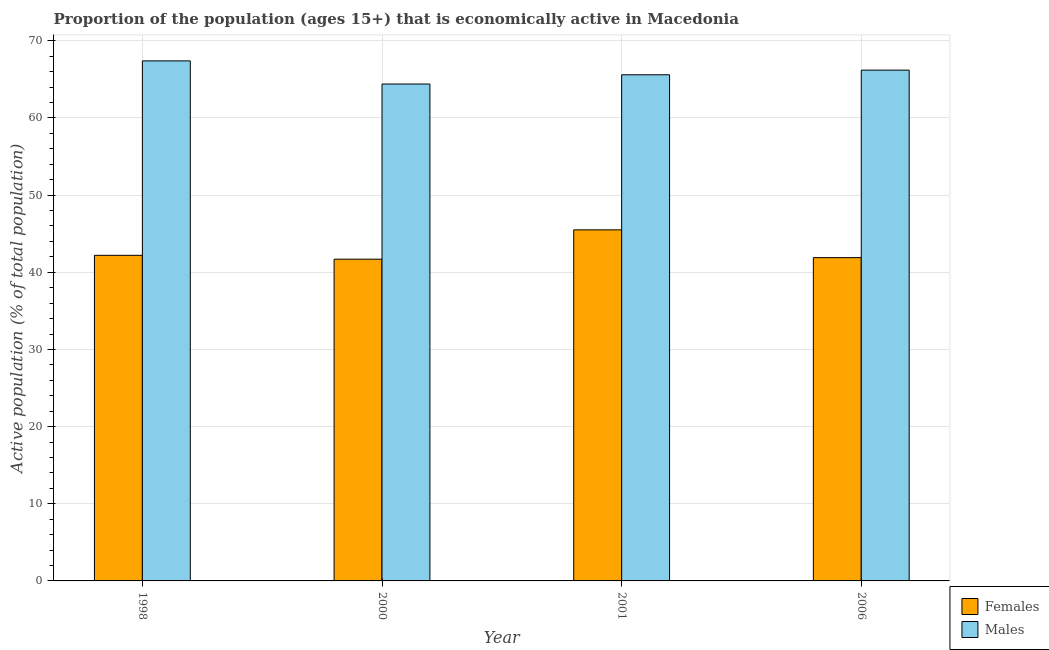How many groups of bars are there?
Keep it short and to the point. 4. Are the number of bars per tick equal to the number of legend labels?
Your answer should be compact. Yes. What is the percentage of economically active male population in 2001?
Give a very brief answer. 65.6. Across all years, what is the maximum percentage of economically active male population?
Ensure brevity in your answer.  67.4. Across all years, what is the minimum percentage of economically active male population?
Give a very brief answer. 64.4. What is the total percentage of economically active female population in the graph?
Provide a succinct answer. 171.3. What is the difference between the percentage of economically active female population in 1998 and that in 2006?
Provide a short and direct response. 0.3. What is the difference between the percentage of economically active male population in 2001 and the percentage of economically active female population in 1998?
Keep it short and to the point. -1.8. What is the average percentage of economically active male population per year?
Keep it short and to the point. 65.9. In the year 2006, what is the difference between the percentage of economically active female population and percentage of economically active male population?
Provide a succinct answer. 0. What is the ratio of the percentage of economically active male population in 1998 to that in 2001?
Make the answer very short. 1.03. Is the difference between the percentage of economically active male population in 1998 and 2000 greater than the difference between the percentage of economically active female population in 1998 and 2000?
Offer a terse response. No. What is the difference between the highest and the second highest percentage of economically active male population?
Give a very brief answer. 1.2. In how many years, is the percentage of economically active male population greater than the average percentage of economically active male population taken over all years?
Provide a short and direct response. 2. What does the 2nd bar from the left in 2006 represents?
Make the answer very short. Males. What does the 2nd bar from the right in 1998 represents?
Make the answer very short. Females. How many years are there in the graph?
Provide a short and direct response. 4. What is the difference between two consecutive major ticks on the Y-axis?
Offer a very short reply. 10. Does the graph contain grids?
Offer a terse response. Yes. How many legend labels are there?
Ensure brevity in your answer.  2. What is the title of the graph?
Ensure brevity in your answer.  Proportion of the population (ages 15+) that is economically active in Macedonia. Does "Resident workers" appear as one of the legend labels in the graph?
Ensure brevity in your answer.  No. What is the label or title of the Y-axis?
Offer a very short reply. Active population (% of total population). What is the Active population (% of total population) in Females in 1998?
Give a very brief answer. 42.2. What is the Active population (% of total population) of Males in 1998?
Provide a succinct answer. 67.4. What is the Active population (% of total population) in Females in 2000?
Offer a very short reply. 41.7. What is the Active population (% of total population) of Males in 2000?
Your answer should be compact. 64.4. What is the Active population (% of total population) of Females in 2001?
Offer a terse response. 45.5. What is the Active population (% of total population) in Males in 2001?
Ensure brevity in your answer.  65.6. What is the Active population (% of total population) in Females in 2006?
Make the answer very short. 41.9. What is the Active population (% of total population) of Males in 2006?
Give a very brief answer. 66.2. Across all years, what is the maximum Active population (% of total population) of Females?
Ensure brevity in your answer.  45.5. Across all years, what is the maximum Active population (% of total population) in Males?
Your answer should be very brief. 67.4. Across all years, what is the minimum Active population (% of total population) of Females?
Your answer should be compact. 41.7. Across all years, what is the minimum Active population (% of total population) in Males?
Provide a succinct answer. 64.4. What is the total Active population (% of total population) in Females in the graph?
Offer a terse response. 171.3. What is the total Active population (% of total population) in Males in the graph?
Provide a short and direct response. 263.6. What is the difference between the Active population (% of total population) in Females in 1998 and that in 2000?
Offer a very short reply. 0.5. What is the difference between the Active population (% of total population) in Males in 1998 and that in 2000?
Your answer should be very brief. 3. What is the difference between the Active population (% of total population) in Females in 1998 and that in 2006?
Your answer should be compact. 0.3. What is the difference between the Active population (% of total population) of Males in 2000 and that in 2006?
Your answer should be compact. -1.8. What is the difference between the Active population (% of total population) of Males in 2001 and that in 2006?
Offer a terse response. -0.6. What is the difference between the Active population (% of total population) in Females in 1998 and the Active population (% of total population) in Males in 2000?
Ensure brevity in your answer.  -22.2. What is the difference between the Active population (% of total population) of Females in 1998 and the Active population (% of total population) of Males in 2001?
Ensure brevity in your answer.  -23.4. What is the difference between the Active population (% of total population) in Females in 2000 and the Active population (% of total population) in Males in 2001?
Your answer should be very brief. -23.9. What is the difference between the Active population (% of total population) of Females in 2000 and the Active population (% of total population) of Males in 2006?
Offer a very short reply. -24.5. What is the difference between the Active population (% of total population) of Females in 2001 and the Active population (% of total population) of Males in 2006?
Your response must be concise. -20.7. What is the average Active population (% of total population) of Females per year?
Provide a succinct answer. 42.83. What is the average Active population (% of total population) in Males per year?
Offer a terse response. 65.9. In the year 1998, what is the difference between the Active population (% of total population) in Females and Active population (% of total population) in Males?
Give a very brief answer. -25.2. In the year 2000, what is the difference between the Active population (% of total population) of Females and Active population (% of total population) of Males?
Ensure brevity in your answer.  -22.7. In the year 2001, what is the difference between the Active population (% of total population) of Females and Active population (% of total population) of Males?
Ensure brevity in your answer.  -20.1. In the year 2006, what is the difference between the Active population (% of total population) in Females and Active population (% of total population) in Males?
Provide a succinct answer. -24.3. What is the ratio of the Active population (% of total population) of Males in 1998 to that in 2000?
Your answer should be very brief. 1.05. What is the ratio of the Active population (% of total population) in Females in 1998 to that in 2001?
Keep it short and to the point. 0.93. What is the ratio of the Active population (% of total population) of Males in 1998 to that in 2001?
Your answer should be compact. 1.03. What is the ratio of the Active population (% of total population) in Males in 1998 to that in 2006?
Ensure brevity in your answer.  1.02. What is the ratio of the Active population (% of total population) of Females in 2000 to that in 2001?
Ensure brevity in your answer.  0.92. What is the ratio of the Active population (% of total population) of Males in 2000 to that in 2001?
Your response must be concise. 0.98. What is the ratio of the Active population (% of total population) of Males in 2000 to that in 2006?
Make the answer very short. 0.97. What is the ratio of the Active population (% of total population) in Females in 2001 to that in 2006?
Give a very brief answer. 1.09. What is the ratio of the Active population (% of total population) of Males in 2001 to that in 2006?
Provide a succinct answer. 0.99. What is the difference between the highest and the second highest Active population (% of total population) in Females?
Give a very brief answer. 3.3. What is the difference between the highest and the lowest Active population (% of total population) in Females?
Give a very brief answer. 3.8. What is the difference between the highest and the lowest Active population (% of total population) of Males?
Keep it short and to the point. 3. 